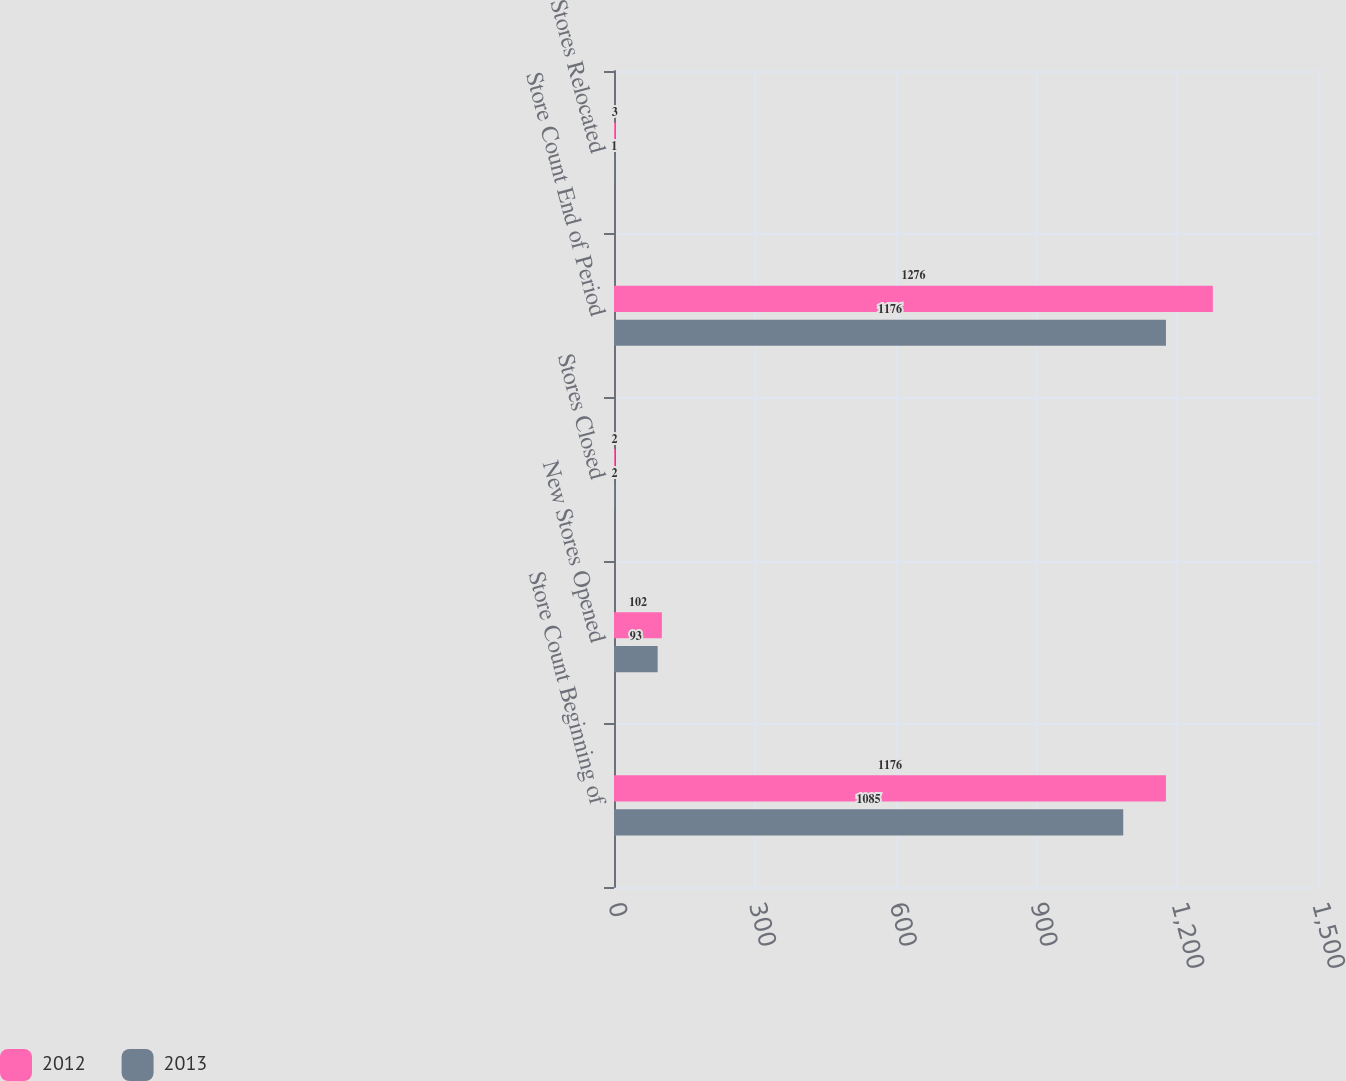Convert chart to OTSL. <chart><loc_0><loc_0><loc_500><loc_500><stacked_bar_chart><ecel><fcel>Store Count Beginning of<fcel>New Stores Opened<fcel>Stores Closed<fcel>Store Count End of Period<fcel>Stores Relocated<nl><fcel>2012<fcel>1176<fcel>102<fcel>2<fcel>1276<fcel>3<nl><fcel>2013<fcel>1085<fcel>93<fcel>2<fcel>1176<fcel>1<nl></chart> 